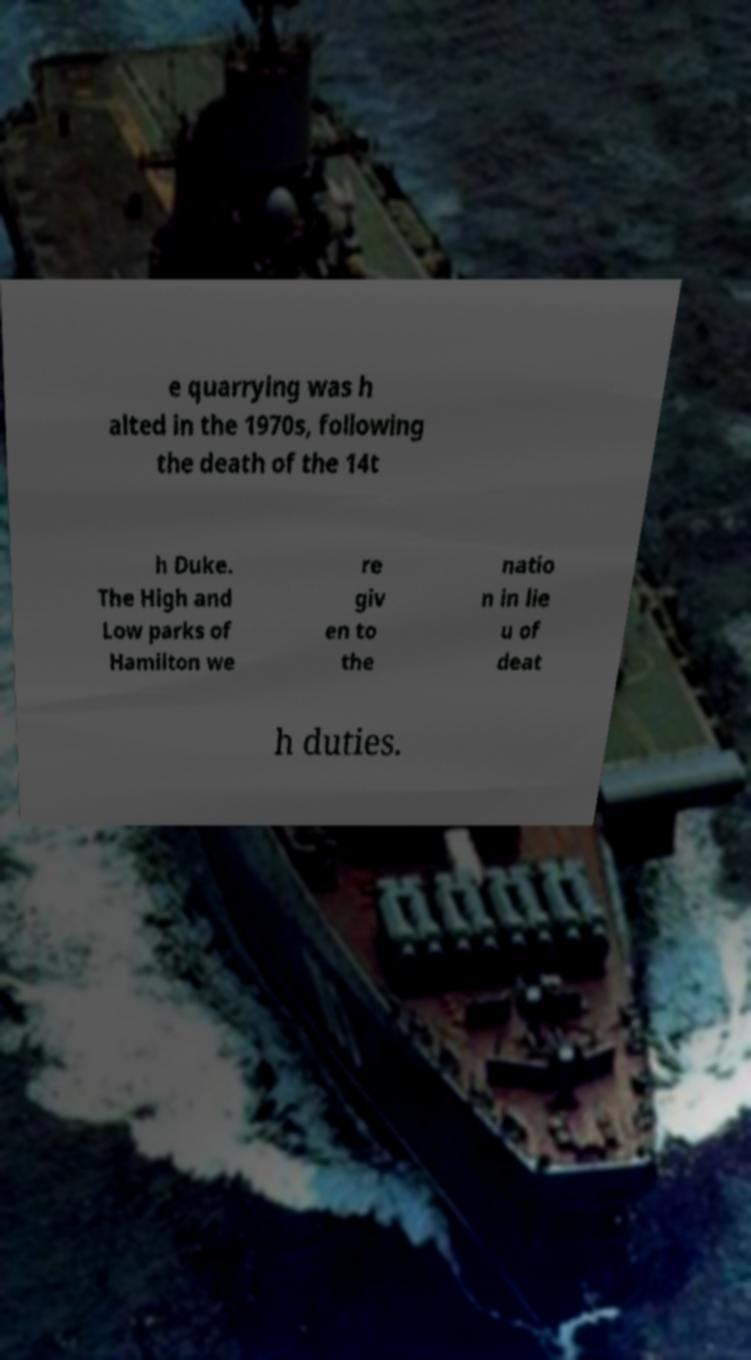There's text embedded in this image that I need extracted. Can you transcribe it verbatim? e quarrying was h alted in the 1970s, following the death of the 14t h Duke. The High and Low parks of Hamilton we re giv en to the natio n in lie u of deat h duties. 